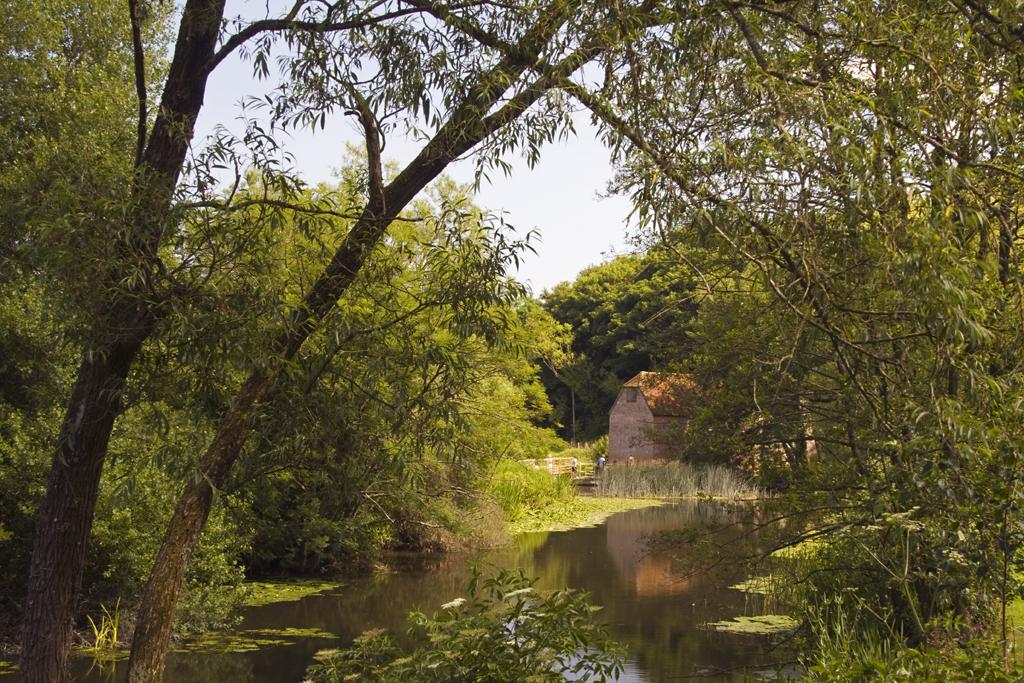What is present in the picture that is not solid? There is water in the picture. What type of vegetation can be seen in the picture? There are trees in the picture. What type of structure is visible in the picture? There is a house in the picture. What can be seen in the background of the picture? The sky is visible in the background of the picture. How many rabbits are hopping through the powder in the picture? There are no rabbits or powder present in the picture. What type of quilt is draped over the house in the picture? There is no quilt present in the picture; it only features a house, trees, water, and the sky. 